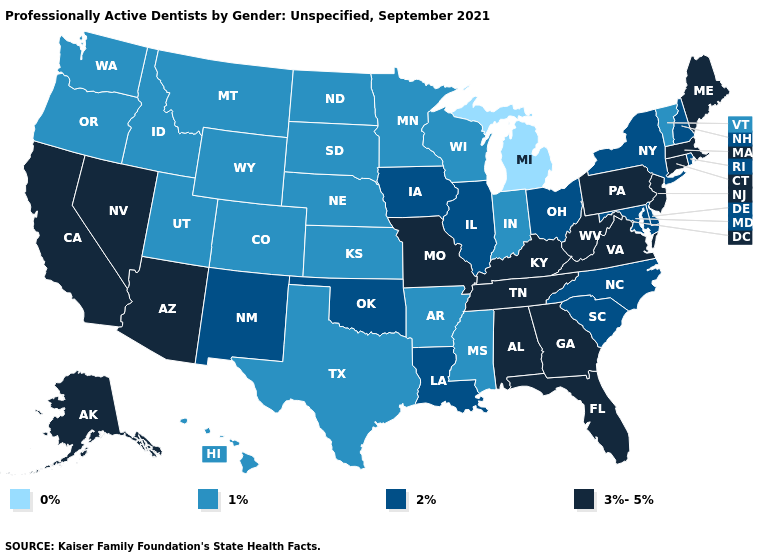Among the states that border Wyoming , which have the highest value?
Concise answer only. Colorado, Idaho, Montana, Nebraska, South Dakota, Utah. What is the value of Connecticut?
Quick response, please. 3%-5%. Is the legend a continuous bar?
Concise answer only. No. What is the value of Tennessee?
Quick response, please. 3%-5%. Among the states that border Missouri , which have the lowest value?
Answer briefly. Arkansas, Kansas, Nebraska. What is the highest value in the USA?
Short answer required. 3%-5%. Name the states that have a value in the range 1%?
Keep it brief. Arkansas, Colorado, Hawaii, Idaho, Indiana, Kansas, Minnesota, Mississippi, Montana, Nebraska, North Dakota, Oregon, South Dakota, Texas, Utah, Vermont, Washington, Wisconsin, Wyoming. What is the value of Arizona?
Keep it brief. 3%-5%. Name the states that have a value in the range 1%?
Concise answer only. Arkansas, Colorado, Hawaii, Idaho, Indiana, Kansas, Minnesota, Mississippi, Montana, Nebraska, North Dakota, Oregon, South Dakota, Texas, Utah, Vermont, Washington, Wisconsin, Wyoming. Among the states that border Virginia , does Kentucky have the highest value?
Be succinct. Yes. Does the first symbol in the legend represent the smallest category?
Write a very short answer. Yes. What is the value of Pennsylvania?
Short answer required. 3%-5%. Name the states that have a value in the range 2%?
Keep it brief. Delaware, Illinois, Iowa, Louisiana, Maryland, New Hampshire, New Mexico, New York, North Carolina, Ohio, Oklahoma, Rhode Island, South Carolina. What is the value of Virginia?
Concise answer only. 3%-5%. 